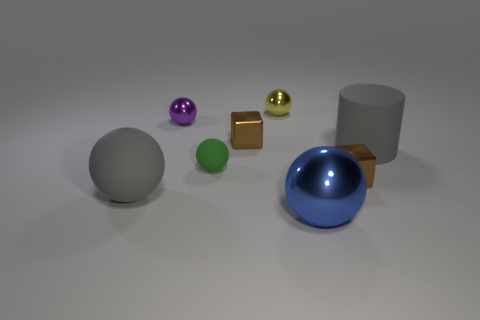Subtract all purple balls. How many balls are left? 4 Add 1 rubber balls. How many objects exist? 9 Subtract all blue spheres. How many spheres are left? 4 Subtract all cylinders. How many objects are left? 7 Add 4 big matte cylinders. How many big matte cylinders are left? 5 Add 5 brown shiny blocks. How many brown shiny blocks exist? 7 Subtract 0 green blocks. How many objects are left? 8 Subtract 1 spheres. How many spheres are left? 4 Subtract all green cylinders. Subtract all green balls. How many cylinders are left? 1 Subtract all small matte things. Subtract all small green spheres. How many objects are left? 6 